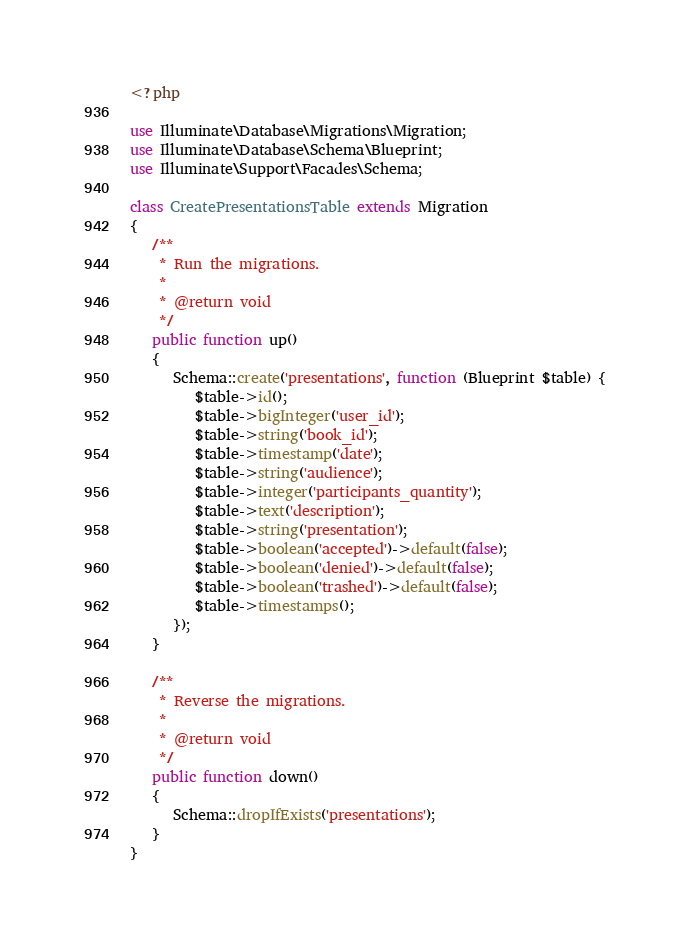<code> <loc_0><loc_0><loc_500><loc_500><_PHP_><?php

use Illuminate\Database\Migrations\Migration;
use Illuminate\Database\Schema\Blueprint;
use Illuminate\Support\Facades\Schema;

class CreatePresentationsTable extends Migration
{
   /**
    * Run the migrations.
    *
    * @return void
    */
   public function up()
   {
      Schema::create('presentations', function (Blueprint $table) {
         $table->id();
         $table->bigInteger('user_id');
         $table->string('book_id');
         $table->timestamp('date');
         $table->string('audience');
         $table->integer('participants_quantity');
         $table->text('description');
         $table->string('presentation');
         $table->boolean('accepted')->default(false);
         $table->boolean('denied')->default(false);
         $table->boolean('trashed')->default(false);
         $table->timestamps();
      });
   }

   /**
    * Reverse the migrations.
    *
    * @return void
    */
   public function down()
   {
      Schema::dropIfExists('presentations');
   }
}
</code> 